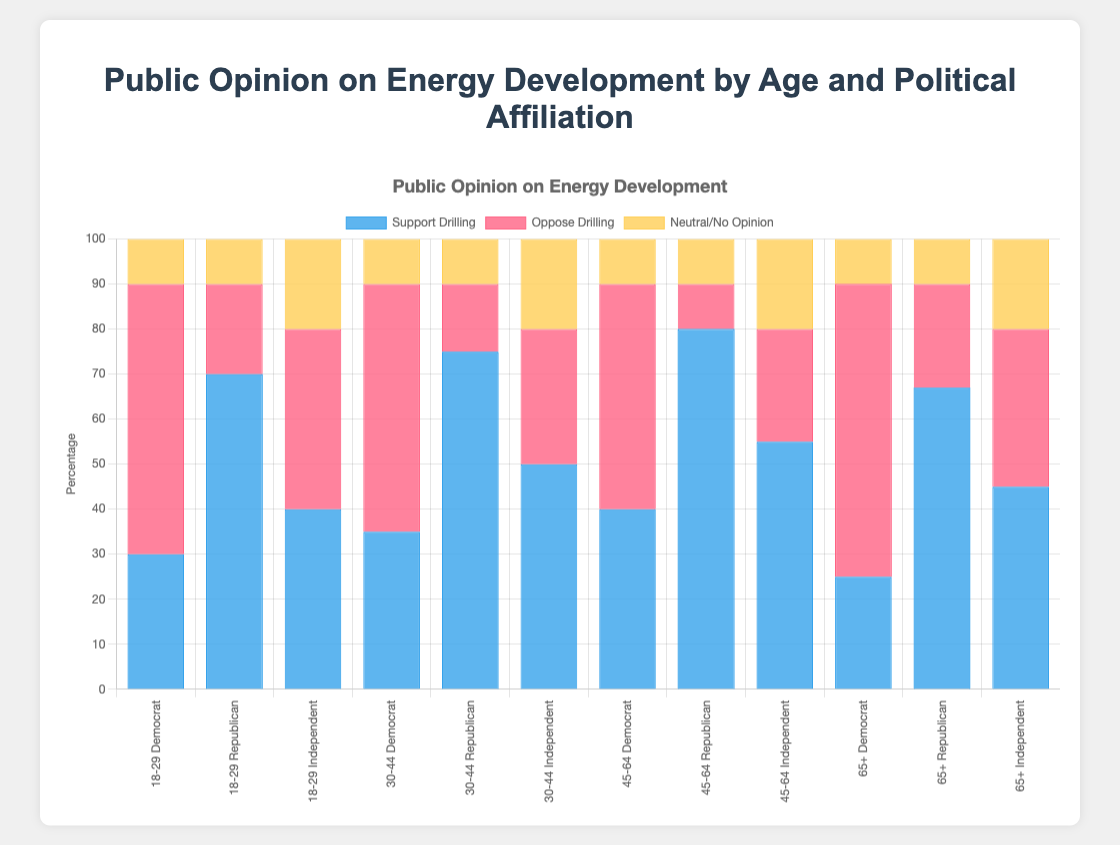Which age group has the highest percentage of support for drilling among Democrats? To find the answer, look at the values for "Support Drilling" among Democrats across all age groups. The values are 30% (18-29), 35% (30-44), 40% (45-64), and 25% (65+). The maximum value is 40% in the 45-64 age group.
Answer: 45-64 Which political affiliation has the least opposition to drilling in the 30-44 age group? Check the "Oppose Drilling" values for the 30-44 age group across different political affiliations. The values are 55% (Democrat), 15% (Republican), and 30% (Independent). The smallest value is 15% for Republicans.
Answer: Republican In the 18-29 age group, what is the total percentage of people who are either neutral or have no opinion on drilling? Add the "Neutral/No Opinion" values for each political affiliation in the 18-29 age group. The values are 10% (Democrat), 10% (Republican), and 20% (Independent). The total is 10% + 10% + 20% = 40%.
Answer: 40% Between Republicans and Democrats aged 65+, who has a higher percentage of support for drilling, and by how much? Compare the "Support Drilling" percentages for Republicans and Democrats in the 65+ age group. The values are 67% (Republican) and 25% (Democrat). The difference is 67% - 25% = 42%.
Answer: Republicans by 42% What is the average percentage of people who support drilling among Independents aged 30-44 and 45-64? Add the "Support Drilling" values for Independents aged 30-44 and 45-64 and divide by 2. The values are 50% (30-44) and 55% (45-64). The average is (50% + 55%) / 2 = 52.5%.
Answer: 52.5% What is the combined percentage of people aged 30-44 and 45-64 who oppose drilling within the Republican group? Add the "Oppose Drilling" values for the Republican group in the age groups 30-44 and 45-64. The values are 15% (30-44) and 10% (45-64). The combined percentage is 15% + 10% = 25%.
Answer: 25% Among Democrats, which age group is most opposed to drilling? Look at the "Oppose Drilling" percentages for Democrats across all age groups. The values are 60% (18-29), 55% (30-44), 50% (45-64), and 65% (65+). The highest value is 65% in the 65+ age group.
Answer: 65+ In which age group do Independents show the highest neutrality towards drilling? Check the "Neutral/No Opinion" percentages for Independents across all age groups. The values are 20% (18-29), 20% (30-44), 20% (45-64), and 20% (65+). All values are equal at 20%.
Answer: All age groups are equal at 20% For Republicans aged 30-44, what is the ratio of those who support drilling to those who oppose it? Find the "Support Drilling" and "Oppose Drilling" values for Republicans aged 30-44, which are 75% and 15% respectively. The ratio is 75% / 15% = 5.
Answer: 5 